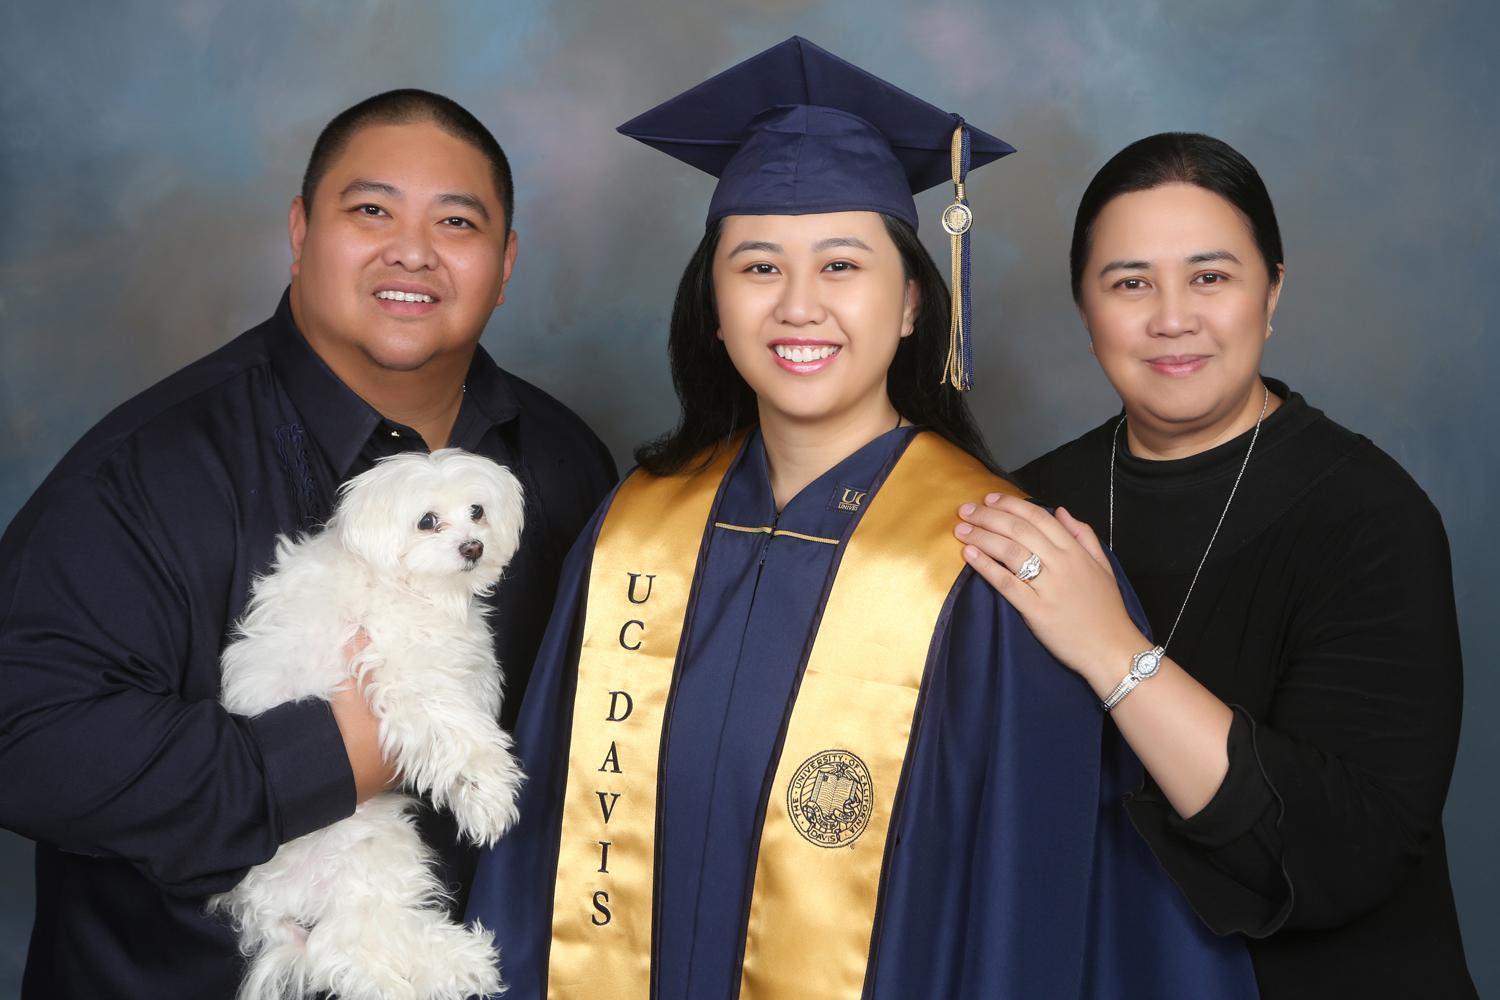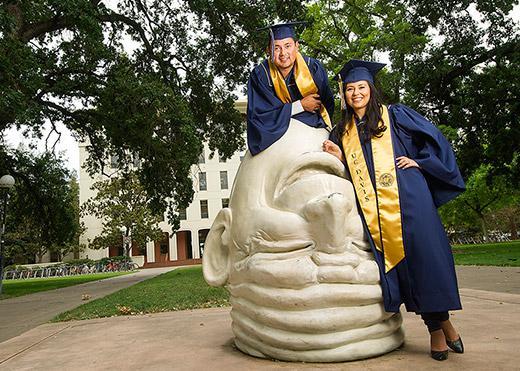The first image is the image on the left, the second image is the image on the right. For the images displayed, is the sentence "Each image contains a long-haired brunette female graduate wearing a sash, robe and hat in the foreground of the picture." factually correct? Answer yes or no. Yes. The first image is the image on the left, the second image is the image on the right. Analyze the images presented: Is the assertion "In the image to the right, the graduation gown is blue." valid? Answer yes or no. Yes. 